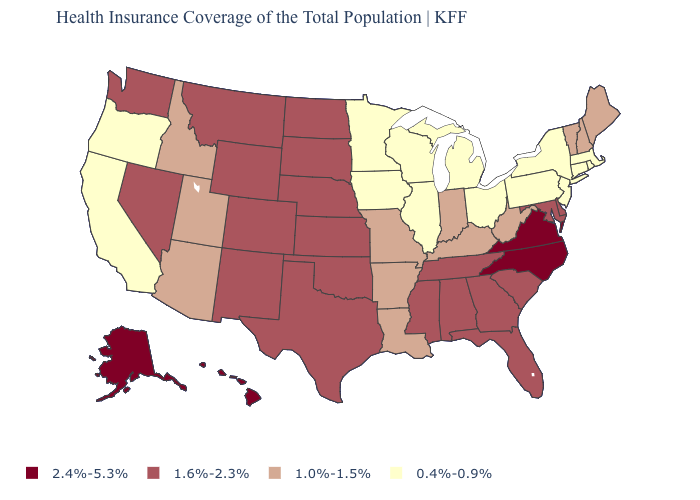Does Maine have the lowest value in the USA?
Concise answer only. No. Among the states that border New Jersey , does New York have the lowest value?
Answer briefly. Yes. Is the legend a continuous bar?
Give a very brief answer. No. Among the states that border New Hampshire , which have the lowest value?
Short answer required. Massachusetts. What is the highest value in the USA?
Answer briefly. 2.4%-5.3%. What is the value of Idaho?
Quick response, please. 1.0%-1.5%. What is the highest value in states that border Maryland?
Answer briefly. 2.4%-5.3%. What is the value of California?
Keep it brief. 0.4%-0.9%. Does Florida have the highest value in the South?
Give a very brief answer. No. Is the legend a continuous bar?
Quick response, please. No. Does the first symbol in the legend represent the smallest category?
Keep it brief. No. Name the states that have a value in the range 2.4%-5.3%?
Answer briefly. Alaska, Hawaii, North Carolina, Virginia. Does the first symbol in the legend represent the smallest category?
Concise answer only. No. What is the value of Connecticut?
Short answer required. 0.4%-0.9%. Does Michigan have the same value as Utah?
Short answer required. No. 